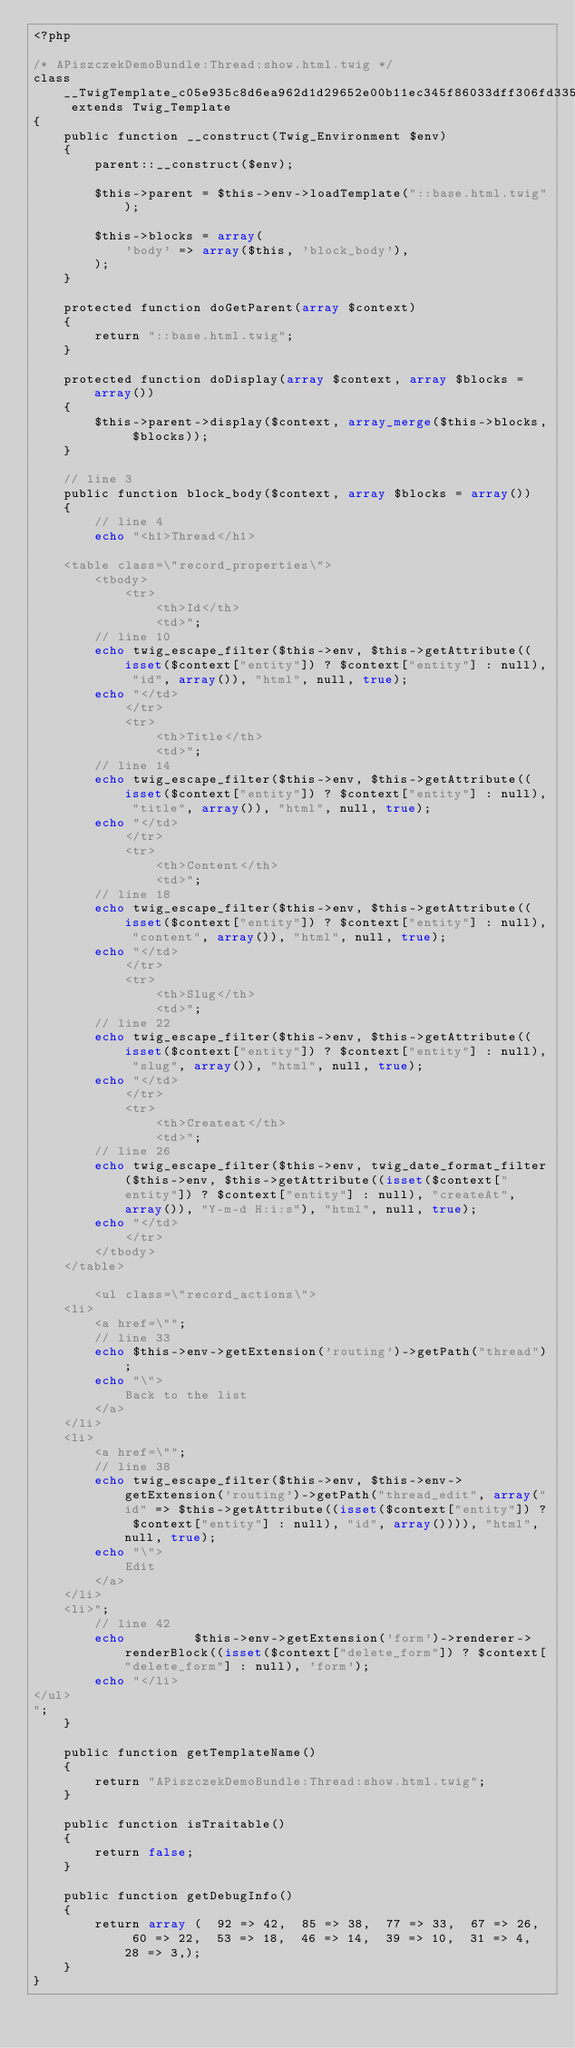<code> <loc_0><loc_0><loc_500><loc_500><_PHP_><?php

/* APiszczekDemoBundle:Thread:show.html.twig */
class __TwigTemplate_c05e935c8d6ea962d1d29652e00b11ec345f86033dff306fd335168102e22fd9 extends Twig_Template
{
    public function __construct(Twig_Environment $env)
    {
        parent::__construct($env);

        $this->parent = $this->env->loadTemplate("::base.html.twig");

        $this->blocks = array(
            'body' => array($this, 'block_body'),
        );
    }

    protected function doGetParent(array $context)
    {
        return "::base.html.twig";
    }

    protected function doDisplay(array $context, array $blocks = array())
    {
        $this->parent->display($context, array_merge($this->blocks, $blocks));
    }

    // line 3
    public function block_body($context, array $blocks = array())
    {
        // line 4
        echo "<h1>Thread</h1>

    <table class=\"record_properties\">
        <tbody>
            <tr>
                <th>Id</th>
                <td>";
        // line 10
        echo twig_escape_filter($this->env, $this->getAttribute((isset($context["entity"]) ? $context["entity"] : null), "id", array()), "html", null, true);
        echo "</td>
            </tr>
            <tr>
                <th>Title</th>
                <td>";
        // line 14
        echo twig_escape_filter($this->env, $this->getAttribute((isset($context["entity"]) ? $context["entity"] : null), "title", array()), "html", null, true);
        echo "</td>
            </tr>
            <tr>
                <th>Content</th>
                <td>";
        // line 18
        echo twig_escape_filter($this->env, $this->getAttribute((isset($context["entity"]) ? $context["entity"] : null), "content", array()), "html", null, true);
        echo "</td>
            </tr>
            <tr>
                <th>Slug</th>
                <td>";
        // line 22
        echo twig_escape_filter($this->env, $this->getAttribute((isset($context["entity"]) ? $context["entity"] : null), "slug", array()), "html", null, true);
        echo "</td>
            </tr>
            <tr>
                <th>Createat</th>
                <td>";
        // line 26
        echo twig_escape_filter($this->env, twig_date_format_filter($this->env, $this->getAttribute((isset($context["entity"]) ? $context["entity"] : null), "createAt", array()), "Y-m-d H:i:s"), "html", null, true);
        echo "</td>
            </tr>
        </tbody>
    </table>

        <ul class=\"record_actions\">
    <li>
        <a href=\"";
        // line 33
        echo $this->env->getExtension('routing')->getPath("thread");
        echo "\">
            Back to the list
        </a>
    </li>
    <li>
        <a href=\"";
        // line 38
        echo twig_escape_filter($this->env, $this->env->getExtension('routing')->getPath("thread_edit", array("id" => $this->getAttribute((isset($context["entity"]) ? $context["entity"] : null), "id", array()))), "html", null, true);
        echo "\">
            Edit
        </a>
    </li>
    <li>";
        // line 42
        echo         $this->env->getExtension('form')->renderer->renderBlock((isset($context["delete_form"]) ? $context["delete_form"] : null), 'form');
        echo "</li>
</ul>
";
    }

    public function getTemplateName()
    {
        return "APiszczekDemoBundle:Thread:show.html.twig";
    }

    public function isTraitable()
    {
        return false;
    }

    public function getDebugInfo()
    {
        return array (  92 => 42,  85 => 38,  77 => 33,  67 => 26,  60 => 22,  53 => 18,  46 => 14,  39 => 10,  31 => 4,  28 => 3,);
    }
}
</code> 